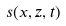Convert formula to latex. <formula><loc_0><loc_0><loc_500><loc_500>s ( x , z , t )</formula> 